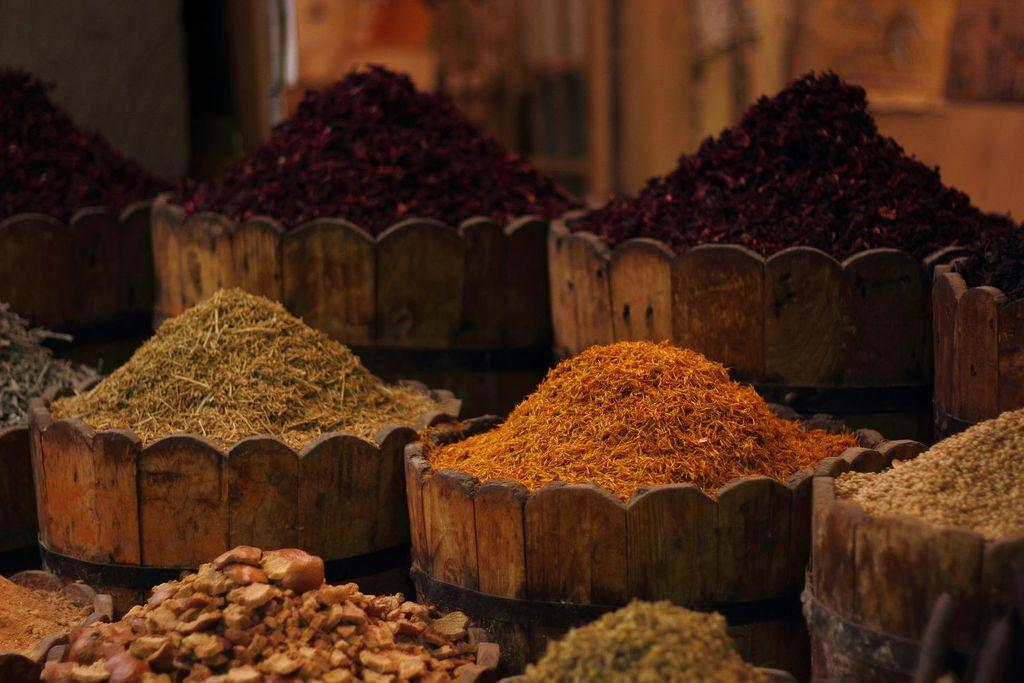What type of bowls are present in the image? There are wooden bowls in the image. What colors of powder can be seen in the image? There is maroon-colored powder, orange-colored powder, and brown-colored powder in the image. How many bees are buzzing around the wooden bowls in the image? There are no bees present in the image; it only features wooden bowls and powders. What type of joke is being told in the image? There is no joke being told in the image; it only features wooden bowls and powders. 